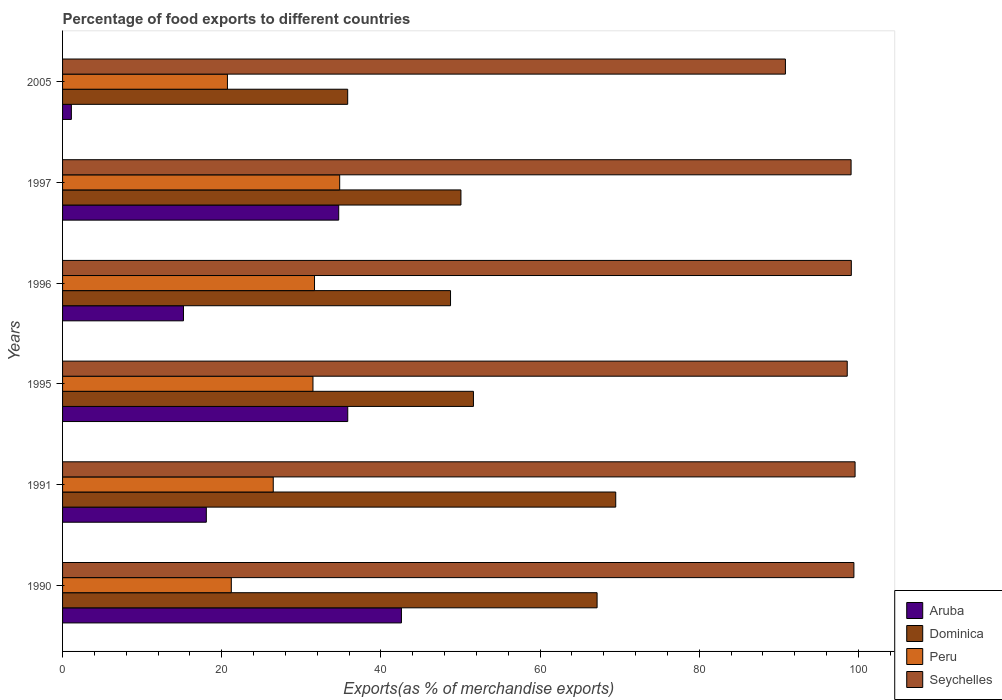Are the number of bars on each tick of the Y-axis equal?
Your answer should be very brief. Yes. How many bars are there on the 4th tick from the top?
Offer a very short reply. 4. How many bars are there on the 6th tick from the bottom?
Your answer should be compact. 4. What is the percentage of exports to different countries in Peru in 1995?
Keep it short and to the point. 31.46. Across all years, what is the maximum percentage of exports to different countries in Dominica?
Give a very brief answer. 69.51. Across all years, what is the minimum percentage of exports to different countries in Aruba?
Offer a very short reply. 1.11. What is the total percentage of exports to different countries in Aruba in the graph?
Offer a very short reply. 147.48. What is the difference between the percentage of exports to different countries in Dominica in 1996 and that in 2005?
Your answer should be compact. 12.92. What is the difference between the percentage of exports to different countries in Aruba in 1990 and the percentage of exports to different countries in Dominica in 1996?
Offer a very short reply. -6.17. What is the average percentage of exports to different countries in Dominica per year?
Keep it short and to the point. 53.82. In the year 1996, what is the difference between the percentage of exports to different countries in Seychelles and percentage of exports to different countries in Peru?
Your answer should be compact. 67.45. What is the ratio of the percentage of exports to different countries in Peru in 1995 to that in 2005?
Your answer should be very brief. 1.52. Is the difference between the percentage of exports to different countries in Seychelles in 1991 and 1995 greater than the difference between the percentage of exports to different countries in Peru in 1991 and 1995?
Make the answer very short. Yes. What is the difference between the highest and the second highest percentage of exports to different countries in Dominica?
Give a very brief answer. 2.34. What is the difference between the highest and the lowest percentage of exports to different countries in Aruba?
Provide a succinct answer. 41.47. Is the sum of the percentage of exports to different countries in Seychelles in 1991 and 2005 greater than the maximum percentage of exports to different countries in Peru across all years?
Offer a terse response. Yes. Is it the case that in every year, the sum of the percentage of exports to different countries in Seychelles and percentage of exports to different countries in Dominica is greater than the sum of percentage of exports to different countries in Aruba and percentage of exports to different countries in Peru?
Make the answer very short. Yes. What does the 2nd bar from the top in 1990 represents?
Your answer should be very brief. Peru. What does the 1st bar from the bottom in 1996 represents?
Your answer should be very brief. Aruba. Are all the bars in the graph horizontal?
Keep it short and to the point. Yes. How many years are there in the graph?
Offer a very short reply. 6. Are the values on the major ticks of X-axis written in scientific E-notation?
Your response must be concise. No. How are the legend labels stacked?
Your answer should be compact. Vertical. What is the title of the graph?
Make the answer very short. Percentage of food exports to different countries. Does "Mexico" appear as one of the legend labels in the graph?
Give a very brief answer. No. What is the label or title of the X-axis?
Provide a succinct answer. Exports(as % of merchandise exports). What is the Exports(as % of merchandise exports) in Aruba in 1990?
Your answer should be compact. 42.58. What is the Exports(as % of merchandise exports) of Dominica in 1990?
Make the answer very short. 67.17. What is the Exports(as % of merchandise exports) of Peru in 1990?
Your answer should be very brief. 21.2. What is the Exports(as % of merchandise exports) of Seychelles in 1990?
Provide a short and direct response. 99.43. What is the Exports(as % of merchandise exports) of Aruba in 1991?
Your answer should be compact. 18.06. What is the Exports(as % of merchandise exports) of Dominica in 1991?
Provide a succinct answer. 69.51. What is the Exports(as % of merchandise exports) of Peru in 1991?
Make the answer very short. 26.47. What is the Exports(as % of merchandise exports) in Seychelles in 1991?
Provide a succinct answer. 99.58. What is the Exports(as % of merchandise exports) of Aruba in 1995?
Keep it short and to the point. 35.83. What is the Exports(as % of merchandise exports) of Dominica in 1995?
Your response must be concise. 51.63. What is the Exports(as % of merchandise exports) in Peru in 1995?
Provide a succinct answer. 31.46. What is the Exports(as % of merchandise exports) in Seychelles in 1995?
Give a very brief answer. 98.6. What is the Exports(as % of merchandise exports) in Aruba in 1996?
Make the answer very short. 15.19. What is the Exports(as % of merchandise exports) of Dominica in 1996?
Keep it short and to the point. 48.75. What is the Exports(as % of merchandise exports) in Peru in 1996?
Make the answer very short. 31.66. What is the Exports(as % of merchandise exports) in Seychelles in 1996?
Provide a short and direct response. 99.11. What is the Exports(as % of merchandise exports) in Aruba in 1997?
Keep it short and to the point. 34.7. What is the Exports(as % of merchandise exports) of Dominica in 1997?
Your response must be concise. 50.06. What is the Exports(as % of merchandise exports) of Peru in 1997?
Provide a short and direct response. 34.82. What is the Exports(as % of merchandise exports) of Seychelles in 1997?
Your answer should be compact. 99.08. What is the Exports(as % of merchandise exports) of Aruba in 2005?
Your answer should be very brief. 1.11. What is the Exports(as % of merchandise exports) of Dominica in 2005?
Keep it short and to the point. 35.83. What is the Exports(as % of merchandise exports) of Peru in 2005?
Offer a very short reply. 20.72. What is the Exports(as % of merchandise exports) of Seychelles in 2005?
Offer a terse response. 90.83. Across all years, what is the maximum Exports(as % of merchandise exports) in Aruba?
Ensure brevity in your answer.  42.58. Across all years, what is the maximum Exports(as % of merchandise exports) of Dominica?
Your response must be concise. 69.51. Across all years, what is the maximum Exports(as % of merchandise exports) of Peru?
Your answer should be very brief. 34.82. Across all years, what is the maximum Exports(as % of merchandise exports) in Seychelles?
Your response must be concise. 99.58. Across all years, what is the minimum Exports(as % of merchandise exports) of Aruba?
Your response must be concise. 1.11. Across all years, what is the minimum Exports(as % of merchandise exports) of Dominica?
Provide a short and direct response. 35.83. Across all years, what is the minimum Exports(as % of merchandise exports) in Peru?
Give a very brief answer. 20.72. Across all years, what is the minimum Exports(as % of merchandise exports) in Seychelles?
Provide a succinct answer. 90.83. What is the total Exports(as % of merchandise exports) of Aruba in the graph?
Give a very brief answer. 147.48. What is the total Exports(as % of merchandise exports) of Dominica in the graph?
Your answer should be very brief. 322.93. What is the total Exports(as % of merchandise exports) of Peru in the graph?
Keep it short and to the point. 166.34. What is the total Exports(as % of merchandise exports) of Seychelles in the graph?
Your answer should be very brief. 586.63. What is the difference between the Exports(as % of merchandise exports) of Aruba in 1990 and that in 1991?
Ensure brevity in your answer.  24.52. What is the difference between the Exports(as % of merchandise exports) of Dominica in 1990 and that in 1991?
Offer a terse response. -2.34. What is the difference between the Exports(as % of merchandise exports) in Peru in 1990 and that in 1991?
Ensure brevity in your answer.  -5.27. What is the difference between the Exports(as % of merchandise exports) of Seychelles in 1990 and that in 1991?
Give a very brief answer. -0.15. What is the difference between the Exports(as % of merchandise exports) in Aruba in 1990 and that in 1995?
Provide a succinct answer. 6.74. What is the difference between the Exports(as % of merchandise exports) of Dominica in 1990 and that in 1995?
Offer a very short reply. 15.54. What is the difference between the Exports(as % of merchandise exports) of Peru in 1990 and that in 1995?
Keep it short and to the point. -10.26. What is the difference between the Exports(as % of merchandise exports) in Seychelles in 1990 and that in 1995?
Offer a very short reply. 0.84. What is the difference between the Exports(as % of merchandise exports) of Aruba in 1990 and that in 1996?
Your response must be concise. 27.38. What is the difference between the Exports(as % of merchandise exports) in Dominica in 1990 and that in 1996?
Provide a short and direct response. 18.42. What is the difference between the Exports(as % of merchandise exports) in Peru in 1990 and that in 1996?
Keep it short and to the point. -10.46. What is the difference between the Exports(as % of merchandise exports) of Seychelles in 1990 and that in 1996?
Ensure brevity in your answer.  0.32. What is the difference between the Exports(as % of merchandise exports) in Aruba in 1990 and that in 1997?
Your answer should be very brief. 7.88. What is the difference between the Exports(as % of merchandise exports) of Dominica in 1990 and that in 1997?
Provide a short and direct response. 17.11. What is the difference between the Exports(as % of merchandise exports) of Peru in 1990 and that in 1997?
Your answer should be very brief. -13.62. What is the difference between the Exports(as % of merchandise exports) in Seychelles in 1990 and that in 1997?
Provide a succinct answer. 0.35. What is the difference between the Exports(as % of merchandise exports) of Aruba in 1990 and that in 2005?
Keep it short and to the point. 41.47. What is the difference between the Exports(as % of merchandise exports) of Dominica in 1990 and that in 2005?
Offer a terse response. 31.34. What is the difference between the Exports(as % of merchandise exports) in Peru in 1990 and that in 2005?
Make the answer very short. 0.49. What is the difference between the Exports(as % of merchandise exports) of Seychelles in 1990 and that in 2005?
Provide a short and direct response. 8.61. What is the difference between the Exports(as % of merchandise exports) in Aruba in 1991 and that in 1995?
Your answer should be compact. -17.77. What is the difference between the Exports(as % of merchandise exports) in Dominica in 1991 and that in 1995?
Provide a short and direct response. 17.88. What is the difference between the Exports(as % of merchandise exports) in Peru in 1991 and that in 1995?
Your answer should be very brief. -4.99. What is the difference between the Exports(as % of merchandise exports) of Seychelles in 1991 and that in 1995?
Your response must be concise. 0.99. What is the difference between the Exports(as % of merchandise exports) of Aruba in 1991 and that in 1996?
Keep it short and to the point. 2.87. What is the difference between the Exports(as % of merchandise exports) in Dominica in 1991 and that in 1996?
Make the answer very short. 20.76. What is the difference between the Exports(as % of merchandise exports) in Peru in 1991 and that in 1996?
Provide a short and direct response. -5.18. What is the difference between the Exports(as % of merchandise exports) in Seychelles in 1991 and that in 1996?
Your response must be concise. 0.47. What is the difference between the Exports(as % of merchandise exports) in Aruba in 1991 and that in 1997?
Ensure brevity in your answer.  -16.64. What is the difference between the Exports(as % of merchandise exports) of Dominica in 1991 and that in 1997?
Your answer should be very brief. 19.45. What is the difference between the Exports(as % of merchandise exports) of Peru in 1991 and that in 1997?
Give a very brief answer. -8.35. What is the difference between the Exports(as % of merchandise exports) in Seychelles in 1991 and that in 1997?
Offer a very short reply. 0.5. What is the difference between the Exports(as % of merchandise exports) of Aruba in 1991 and that in 2005?
Your answer should be compact. 16.96. What is the difference between the Exports(as % of merchandise exports) in Dominica in 1991 and that in 2005?
Your response must be concise. 33.68. What is the difference between the Exports(as % of merchandise exports) in Peru in 1991 and that in 2005?
Your answer should be compact. 5.76. What is the difference between the Exports(as % of merchandise exports) in Seychelles in 1991 and that in 2005?
Provide a short and direct response. 8.75. What is the difference between the Exports(as % of merchandise exports) in Aruba in 1995 and that in 1996?
Offer a terse response. 20.64. What is the difference between the Exports(as % of merchandise exports) of Dominica in 1995 and that in 1996?
Give a very brief answer. 2.88. What is the difference between the Exports(as % of merchandise exports) in Peru in 1995 and that in 1996?
Provide a succinct answer. -0.19. What is the difference between the Exports(as % of merchandise exports) of Seychelles in 1995 and that in 1996?
Offer a terse response. -0.51. What is the difference between the Exports(as % of merchandise exports) in Aruba in 1995 and that in 1997?
Give a very brief answer. 1.13. What is the difference between the Exports(as % of merchandise exports) in Dominica in 1995 and that in 1997?
Your response must be concise. 1.57. What is the difference between the Exports(as % of merchandise exports) of Peru in 1995 and that in 1997?
Ensure brevity in your answer.  -3.36. What is the difference between the Exports(as % of merchandise exports) of Seychelles in 1995 and that in 1997?
Offer a terse response. -0.48. What is the difference between the Exports(as % of merchandise exports) in Aruba in 1995 and that in 2005?
Give a very brief answer. 34.73. What is the difference between the Exports(as % of merchandise exports) of Dominica in 1995 and that in 2005?
Your answer should be very brief. 15.8. What is the difference between the Exports(as % of merchandise exports) of Peru in 1995 and that in 2005?
Provide a short and direct response. 10.75. What is the difference between the Exports(as % of merchandise exports) of Seychelles in 1995 and that in 2005?
Offer a terse response. 7.77. What is the difference between the Exports(as % of merchandise exports) of Aruba in 1996 and that in 1997?
Provide a succinct answer. -19.5. What is the difference between the Exports(as % of merchandise exports) in Dominica in 1996 and that in 1997?
Give a very brief answer. -1.31. What is the difference between the Exports(as % of merchandise exports) of Peru in 1996 and that in 1997?
Keep it short and to the point. -3.16. What is the difference between the Exports(as % of merchandise exports) of Seychelles in 1996 and that in 1997?
Give a very brief answer. 0.03. What is the difference between the Exports(as % of merchandise exports) of Aruba in 1996 and that in 2005?
Provide a succinct answer. 14.09. What is the difference between the Exports(as % of merchandise exports) of Dominica in 1996 and that in 2005?
Make the answer very short. 12.92. What is the difference between the Exports(as % of merchandise exports) in Peru in 1996 and that in 2005?
Your answer should be compact. 10.94. What is the difference between the Exports(as % of merchandise exports) in Seychelles in 1996 and that in 2005?
Provide a short and direct response. 8.28. What is the difference between the Exports(as % of merchandise exports) in Aruba in 1997 and that in 2005?
Your answer should be very brief. 33.59. What is the difference between the Exports(as % of merchandise exports) in Dominica in 1997 and that in 2005?
Make the answer very short. 14.23. What is the difference between the Exports(as % of merchandise exports) of Peru in 1997 and that in 2005?
Offer a terse response. 14.1. What is the difference between the Exports(as % of merchandise exports) in Seychelles in 1997 and that in 2005?
Ensure brevity in your answer.  8.25. What is the difference between the Exports(as % of merchandise exports) in Aruba in 1990 and the Exports(as % of merchandise exports) in Dominica in 1991?
Your answer should be very brief. -26.93. What is the difference between the Exports(as % of merchandise exports) of Aruba in 1990 and the Exports(as % of merchandise exports) of Peru in 1991?
Offer a terse response. 16.11. What is the difference between the Exports(as % of merchandise exports) of Aruba in 1990 and the Exports(as % of merchandise exports) of Seychelles in 1991?
Offer a very short reply. -57. What is the difference between the Exports(as % of merchandise exports) in Dominica in 1990 and the Exports(as % of merchandise exports) in Peru in 1991?
Keep it short and to the point. 40.69. What is the difference between the Exports(as % of merchandise exports) in Dominica in 1990 and the Exports(as % of merchandise exports) in Seychelles in 1991?
Provide a succinct answer. -32.42. What is the difference between the Exports(as % of merchandise exports) of Peru in 1990 and the Exports(as % of merchandise exports) of Seychelles in 1991?
Your response must be concise. -78.38. What is the difference between the Exports(as % of merchandise exports) in Aruba in 1990 and the Exports(as % of merchandise exports) in Dominica in 1995?
Your answer should be compact. -9.05. What is the difference between the Exports(as % of merchandise exports) in Aruba in 1990 and the Exports(as % of merchandise exports) in Peru in 1995?
Give a very brief answer. 11.11. What is the difference between the Exports(as % of merchandise exports) of Aruba in 1990 and the Exports(as % of merchandise exports) of Seychelles in 1995?
Make the answer very short. -56.02. What is the difference between the Exports(as % of merchandise exports) of Dominica in 1990 and the Exports(as % of merchandise exports) of Peru in 1995?
Your answer should be compact. 35.7. What is the difference between the Exports(as % of merchandise exports) of Dominica in 1990 and the Exports(as % of merchandise exports) of Seychelles in 1995?
Your answer should be very brief. -31.43. What is the difference between the Exports(as % of merchandise exports) of Peru in 1990 and the Exports(as % of merchandise exports) of Seychelles in 1995?
Make the answer very short. -77.39. What is the difference between the Exports(as % of merchandise exports) of Aruba in 1990 and the Exports(as % of merchandise exports) of Dominica in 1996?
Ensure brevity in your answer.  -6.17. What is the difference between the Exports(as % of merchandise exports) of Aruba in 1990 and the Exports(as % of merchandise exports) of Peru in 1996?
Keep it short and to the point. 10.92. What is the difference between the Exports(as % of merchandise exports) in Aruba in 1990 and the Exports(as % of merchandise exports) in Seychelles in 1996?
Give a very brief answer. -56.53. What is the difference between the Exports(as % of merchandise exports) in Dominica in 1990 and the Exports(as % of merchandise exports) in Peru in 1996?
Keep it short and to the point. 35.51. What is the difference between the Exports(as % of merchandise exports) in Dominica in 1990 and the Exports(as % of merchandise exports) in Seychelles in 1996?
Offer a very short reply. -31.95. What is the difference between the Exports(as % of merchandise exports) of Peru in 1990 and the Exports(as % of merchandise exports) of Seychelles in 1996?
Make the answer very short. -77.91. What is the difference between the Exports(as % of merchandise exports) of Aruba in 1990 and the Exports(as % of merchandise exports) of Dominica in 1997?
Keep it short and to the point. -7.48. What is the difference between the Exports(as % of merchandise exports) in Aruba in 1990 and the Exports(as % of merchandise exports) in Peru in 1997?
Offer a very short reply. 7.76. What is the difference between the Exports(as % of merchandise exports) of Aruba in 1990 and the Exports(as % of merchandise exports) of Seychelles in 1997?
Your response must be concise. -56.5. What is the difference between the Exports(as % of merchandise exports) in Dominica in 1990 and the Exports(as % of merchandise exports) in Peru in 1997?
Your answer should be very brief. 32.34. What is the difference between the Exports(as % of merchandise exports) of Dominica in 1990 and the Exports(as % of merchandise exports) of Seychelles in 1997?
Ensure brevity in your answer.  -31.91. What is the difference between the Exports(as % of merchandise exports) of Peru in 1990 and the Exports(as % of merchandise exports) of Seychelles in 1997?
Your answer should be very brief. -77.88. What is the difference between the Exports(as % of merchandise exports) in Aruba in 1990 and the Exports(as % of merchandise exports) in Dominica in 2005?
Your answer should be very brief. 6.75. What is the difference between the Exports(as % of merchandise exports) in Aruba in 1990 and the Exports(as % of merchandise exports) in Peru in 2005?
Make the answer very short. 21.86. What is the difference between the Exports(as % of merchandise exports) in Aruba in 1990 and the Exports(as % of merchandise exports) in Seychelles in 2005?
Ensure brevity in your answer.  -48.25. What is the difference between the Exports(as % of merchandise exports) of Dominica in 1990 and the Exports(as % of merchandise exports) of Peru in 2005?
Provide a succinct answer. 46.45. What is the difference between the Exports(as % of merchandise exports) in Dominica in 1990 and the Exports(as % of merchandise exports) in Seychelles in 2005?
Provide a short and direct response. -23.66. What is the difference between the Exports(as % of merchandise exports) of Peru in 1990 and the Exports(as % of merchandise exports) of Seychelles in 2005?
Offer a terse response. -69.63. What is the difference between the Exports(as % of merchandise exports) in Aruba in 1991 and the Exports(as % of merchandise exports) in Dominica in 1995?
Offer a terse response. -33.56. What is the difference between the Exports(as % of merchandise exports) in Aruba in 1991 and the Exports(as % of merchandise exports) in Peru in 1995?
Your answer should be very brief. -13.4. What is the difference between the Exports(as % of merchandise exports) of Aruba in 1991 and the Exports(as % of merchandise exports) of Seychelles in 1995?
Provide a short and direct response. -80.53. What is the difference between the Exports(as % of merchandise exports) of Dominica in 1991 and the Exports(as % of merchandise exports) of Peru in 1995?
Offer a terse response. 38.04. What is the difference between the Exports(as % of merchandise exports) in Dominica in 1991 and the Exports(as % of merchandise exports) in Seychelles in 1995?
Provide a short and direct response. -29.09. What is the difference between the Exports(as % of merchandise exports) of Peru in 1991 and the Exports(as % of merchandise exports) of Seychelles in 1995?
Ensure brevity in your answer.  -72.12. What is the difference between the Exports(as % of merchandise exports) of Aruba in 1991 and the Exports(as % of merchandise exports) of Dominica in 1996?
Your response must be concise. -30.68. What is the difference between the Exports(as % of merchandise exports) of Aruba in 1991 and the Exports(as % of merchandise exports) of Peru in 1996?
Ensure brevity in your answer.  -13.6. What is the difference between the Exports(as % of merchandise exports) of Aruba in 1991 and the Exports(as % of merchandise exports) of Seychelles in 1996?
Your response must be concise. -81.05. What is the difference between the Exports(as % of merchandise exports) in Dominica in 1991 and the Exports(as % of merchandise exports) in Peru in 1996?
Provide a succinct answer. 37.85. What is the difference between the Exports(as % of merchandise exports) of Dominica in 1991 and the Exports(as % of merchandise exports) of Seychelles in 1996?
Make the answer very short. -29.6. What is the difference between the Exports(as % of merchandise exports) in Peru in 1991 and the Exports(as % of merchandise exports) in Seychelles in 1996?
Make the answer very short. -72.64. What is the difference between the Exports(as % of merchandise exports) in Aruba in 1991 and the Exports(as % of merchandise exports) in Dominica in 1997?
Provide a short and direct response. -31.99. What is the difference between the Exports(as % of merchandise exports) in Aruba in 1991 and the Exports(as % of merchandise exports) in Peru in 1997?
Provide a short and direct response. -16.76. What is the difference between the Exports(as % of merchandise exports) of Aruba in 1991 and the Exports(as % of merchandise exports) of Seychelles in 1997?
Provide a succinct answer. -81.02. What is the difference between the Exports(as % of merchandise exports) in Dominica in 1991 and the Exports(as % of merchandise exports) in Peru in 1997?
Make the answer very short. 34.69. What is the difference between the Exports(as % of merchandise exports) of Dominica in 1991 and the Exports(as % of merchandise exports) of Seychelles in 1997?
Your response must be concise. -29.57. What is the difference between the Exports(as % of merchandise exports) of Peru in 1991 and the Exports(as % of merchandise exports) of Seychelles in 1997?
Provide a short and direct response. -72.61. What is the difference between the Exports(as % of merchandise exports) of Aruba in 1991 and the Exports(as % of merchandise exports) of Dominica in 2005?
Make the answer very short. -17.76. What is the difference between the Exports(as % of merchandise exports) of Aruba in 1991 and the Exports(as % of merchandise exports) of Peru in 2005?
Keep it short and to the point. -2.65. What is the difference between the Exports(as % of merchandise exports) of Aruba in 1991 and the Exports(as % of merchandise exports) of Seychelles in 2005?
Provide a short and direct response. -72.77. What is the difference between the Exports(as % of merchandise exports) in Dominica in 1991 and the Exports(as % of merchandise exports) in Peru in 2005?
Make the answer very short. 48.79. What is the difference between the Exports(as % of merchandise exports) of Dominica in 1991 and the Exports(as % of merchandise exports) of Seychelles in 2005?
Ensure brevity in your answer.  -21.32. What is the difference between the Exports(as % of merchandise exports) in Peru in 1991 and the Exports(as % of merchandise exports) in Seychelles in 2005?
Provide a succinct answer. -64.35. What is the difference between the Exports(as % of merchandise exports) in Aruba in 1995 and the Exports(as % of merchandise exports) in Dominica in 1996?
Ensure brevity in your answer.  -12.91. What is the difference between the Exports(as % of merchandise exports) of Aruba in 1995 and the Exports(as % of merchandise exports) of Peru in 1996?
Your answer should be very brief. 4.18. What is the difference between the Exports(as % of merchandise exports) in Aruba in 1995 and the Exports(as % of merchandise exports) in Seychelles in 1996?
Provide a succinct answer. -63.28. What is the difference between the Exports(as % of merchandise exports) of Dominica in 1995 and the Exports(as % of merchandise exports) of Peru in 1996?
Give a very brief answer. 19.97. What is the difference between the Exports(as % of merchandise exports) in Dominica in 1995 and the Exports(as % of merchandise exports) in Seychelles in 1996?
Give a very brief answer. -47.48. What is the difference between the Exports(as % of merchandise exports) of Peru in 1995 and the Exports(as % of merchandise exports) of Seychelles in 1996?
Provide a succinct answer. -67.65. What is the difference between the Exports(as % of merchandise exports) of Aruba in 1995 and the Exports(as % of merchandise exports) of Dominica in 1997?
Your answer should be compact. -14.22. What is the difference between the Exports(as % of merchandise exports) in Aruba in 1995 and the Exports(as % of merchandise exports) in Peru in 1997?
Ensure brevity in your answer.  1.01. What is the difference between the Exports(as % of merchandise exports) in Aruba in 1995 and the Exports(as % of merchandise exports) in Seychelles in 1997?
Your response must be concise. -63.25. What is the difference between the Exports(as % of merchandise exports) in Dominica in 1995 and the Exports(as % of merchandise exports) in Peru in 1997?
Make the answer very short. 16.8. What is the difference between the Exports(as % of merchandise exports) of Dominica in 1995 and the Exports(as % of merchandise exports) of Seychelles in 1997?
Make the answer very short. -47.45. What is the difference between the Exports(as % of merchandise exports) in Peru in 1995 and the Exports(as % of merchandise exports) in Seychelles in 1997?
Ensure brevity in your answer.  -67.62. What is the difference between the Exports(as % of merchandise exports) in Aruba in 1995 and the Exports(as % of merchandise exports) in Dominica in 2005?
Offer a very short reply. 0.01. What is the difference between the Exports(as % of merchandise exports) in Aruba in 1995 and the Exports(as % of merchandise exports) in Peru in 2005?
Offer a very short reply. 15.12. What is the difference between the Exports(as % of merchandise exports) of Aruba in 1995 and the Exports(as % of merchandise exports) of Seychelles in 2005?
Your answer should be very brief. -54.99. What is the difference between the Exports(as % of merchandise exports) in Dominica in 1995 and the Exports(as % of merchandise exports) in Peru in 2005?
Offer a terse response. 30.91. What is the difference between the Exports(as % of merchandise exports) of Dominica in 1995 and the Exports(as % of merchandise exports) of Seychelles in 2005?
Make the answer very short. -39.2. What is the difference between the Exports(as % of merchandise exports) of Peru in 1995 and the Exports(as % of merchandise exports) of Seychelles in 2005?
Provide a succinct answer. -59.36. What is the difference between the Exports(as % of merchandise exports) of Aruba in 1996 and the Exports(as % of merchandise exports) of Dominica in 1997?
Provide a short and direct response. -34.86. What is the difference between the Exports(as % of merchandise exports) of Aruba in 1996 and the Exports(as % of merchandise exports) of Peru in 1997?
Ensure brevity in your answer.  -19.63. What is the difference between the Exports(as % of merchandise exports) of Aruba in 1996 and the Exports(as % of merchandise exports) of Seychelles in 1997?
Your response must be concise. -83.89. What is the difference between the Exports(as % of merchandise exports) in Dominica in 1996 and the Exports(as % of merchandise exports) in Peru in 1997?
Give a very brief answer. 13.93. What is the difference between the Exports(as % of merchandise exports) of Dominica in 1996 and the Exports(as % of merchandise exports) of Seychelles in 1997?
Your response must be concise. -50.33. What is the difference between the Exports(as % of merchandise exports) of Peru in 1996 and the Exports(as % of merchandise exports) of Seychelles in 1997?
Provide a succinct answer. -67.42. What is the difference between the Exports(as % of merchandise exports) in Aruba in 1996 and the Exports(as % of merchandise exports) in Dominica in 2005?
Keep it short and to the point. -20.63. What is the difference between the Exports(as % of merchandise exports) in Aruba in 1996 and the Exports(as % of merchandise exports) in Peru in 2005?
Give a very brief answer. -5.52. What is the difference between the Exports(as % of merchandise exports) in Aruba in 1996 and the Exports(as % of merchandise exports) in Seychelles in 2005?
Your answer should be very brief. -75.63. What is the difference between the Exports(as % of merchandise exports) in Dominica in 1996 and the Exports(as % of merchandise exports) in Peru in 2005?
Your response must be concise. 28.03. What is the difference between the Exports(as % of merchandise exports) in Dominica in 1996 and the Exports(as % of merchandise exports) in Seychelles in 2005?
Give a very brief answer. -42.08. What is the difference between the Exports(as % of merchandise exports) in Peru in 1996 and the Exports(as % of merchandise exports) in Seychelles in 2005?
Your response must be concise. -59.17. What is the difference between the Exports(as % of merchandise exports) in Aruba in 1997 and the Exports(as % of merchandise exports) in Dominica in 2005?
Keep it short and to the point. -1.13. What is the difference between the Exports(as % of merchandise exports) of Aruba in 1997 and the Exports(as % of merchandise exports) of Peru in 2005?
Your answer should be compact. 13.98. What is the difference between the Exports(as % of merchandise exports) in Aruba in 1997 and the Exports(as % of merchandise exports) in Seychelles in 2005?
Ensure brevity in your answer.  -56.13. What is the difference between the Exports(as % of merchandise exports) of Dominica in 1997 and the Exports(as % of merchandise exports) of Peru in 2005?
Your response must be concise. 29.34. What is the difference between the Exports(as % of merchandise exports) in Dominica in 1997 and the Exports(as % of merchandise exports) in Seychelles in 2005?
Provide a short and direct response. -40.77. What is the difference between the Exports(as % of merchandise exports) in Peru in 1997 and the Exports(as % of merchandise exports) in Seychelles in 2005?
Ensure brevity in your answer.  -56.01. What is the average Exports(as % of merchandise exports) in Aruba per year?
Provide a short and direct response. 24.58. What is the average Exports(as % of merchandise exports) of Dominica per year?
Your answer should be very brief. 53.82. What is the average Exports(as % of merchandise exports) of Peru per year?
Offer a terse response. 27.72. What is the average Exports(as % of merchandise exports) in Seychelles per year?
Offer a terse response. 97.77. In the year 1990, what is the difference between the Exports(as % of merchandise exports) of Aruba and Exports(as % of merchandise exports) of Dominica?
Your answer should be compact. -24.59. In the year 1990, what is the difference between the Exports(as % of merchandise exports) in Aruba and Exports(as % of merchandise exports) in Peru?
Your answer should be compact. 21.38. In the year 1990, what is the difference between the Exports(as % of merchandise exports) in Aruba and Exports(as % of merchandise exports) in Seychelles?
Your response must be concise. -56.85. In the year 1990, what is the difference between the Exports(as % of merchandise exports) of Dominica and Exports(as % of merchandise exports) of Peru?
Provide a short and direct response. 45.96. In the year 1990, what is the difference between the Exports(as % of merchandise exports) in Dominica and Exports(as % of merchandise exports) in Seychelles?
Offer a terse response. -32.27. In the year 1990, what is the difference between the Exports(as % of merchandise exports) of Peru and Exports(as % of merchandise exports) of Seychelles?
Offer a very short reply. -78.23. In the year 1991, what is the difference between the Exports(as % of merchandise exports) of Aruba and Exports(as % of merchandise exports) of Dominica?
Provide a succinct answer. -51.44. In the year 1991, what is the difference between the Exports(as % of merchandise exports) of Aruba and Exports(as % of merchandise exports) of Peru?
Offer a very short reply. -8.41. In the year 1991, what is the difference between the Exports(as % of merchandise exports) of Aruba and Exports(as % of merchandise exports) of Seychelles?
Ensure brevity in your answer.  -81.52. In the year 1991, what is the difference between the Exports(as % of merchandise exports) of Dominica and Exports(as % of merchandise exports) of Peru?
Provide a succinct answer. 43.03. In the year 1991, what is the difference between the Exports(as % of merchandise exports) in Dominica and Exports(as % of merchandise exports) in Seychelles?
Keep it short and to the point. -30.07. In the year 1991, what is the difference between the Exports(as % of merchandise exports) of Peru and Exports(as % of merchandise exports) of Seychelles?
Keep it short and to the point. -73.11. In the year 1995, what is the difference between the Exports(as % of merchandise exports) of Aruba and Exports(as % of merchandise exports) of Dominica?
Offer a very short reply. -15.79. In the year 1995, what is the difference between the Exports(as % of merchandise exports) in Aruba and Exports(as % of merchandise exports) in Peru?
Your answer should be very brief. 4.37. In the year 1995, what is the difference between the Exports(as % of merchandise exports) of Aruba and Exports(as % of merchandise exports) of Seychelles?
Your answer should be compact. -62.76. In the year 1995, what is the difference between the Exports(as % of merchandise exports) of Dominica and Exports(as % of merchandise exports) of Peru?
Give a very brief answer. 20.16. In the year 1995, what is the difference between the Exports(as % of merchandise exports) in Dominica and Exports(as % of merchandise exports) in Seychelles?
Offer a terse response. -46.97. In the year 1995, what is the difference between the Exports(as % of merchandise exports) in Peru and Exports(as % of merchandise exports) in Seychelles?
Offer a very short reply. -67.13. In the year 1996, what is the difference between the Exports(as % of merchandise exports) in Aruba and Exports(as % of merchandise exports) in Dominica?
Keep it short and to the point. -33.55. In the year 1996, what is the difference between the Exports(as % of merchandise exports) of Aruba and Exports(as % of merchandise exports) of Peru?
Keep it short and to the point. -16.46. In the year 1996, what is the difference between the Exports(as % of merchandise exports) of Aruba and Exports(as % of merchandise exports) of Seychelles?
Provide a short and direct response. -83.92. In the year 1996, what is the difference between the Exports(as % of merchandise exports) in Dominica and Exports(as % of merchandise exports) in Peru?
Ensure brevity in your answer.  17.09. In the year 1996, what is the difference between the Exports(as % of merchandise exports) in Dominica and Exports(as % of merchandise exports) in Seychelles?
Provide a succinct answer. -50.36. In the year 1996, what is the difference between the Exports(as % of merchandise exports) of Peru and Exports(as % of merchandise exports) of Seychelles?
Offer a very short reply. -67.45. In the year 1997, what is the difference between the Exports(as % of merchandise exports) in Aruba and Exports(as % of merchandise exports) in Dominica?
Provide a succinct answer. -15.36. In the year 1997, what is the difference between the Exports(as % of merchandise exports) in Aruba and Exports(as % of merchandise exports) in Peru?
Your response must be concise. -0.12. In the year 1997, what is the difference between the Exports(as % of merchandise exports) of Aruba and Exports(as % of merchandise exports) of Seychelles?
Ensure brevity in your answer.  -64.38. In the year 1997, what is the difference between the Exports(as % of merchandise exports) of Dominica and Exports(as % of merchandise exports) of Peru?
Offer a very short reply. 15.24. In the year 1997, what is the difference between the Exports(as % of merchandise exports) in Dominica and Exports(as % of merchandise exports) in Seychelles?
Offer a very short reply. -49.02. In the year 1997, what is the difference between the Exports(as % of merchandise exports) in Peru and Exports(as % of merchandise exports) in Seychelles?
Your answer should be very brief. -64.26. In the year 2005, what is the difference between the Exports(as % of merchandise exports) in Aruba and Exports(as % of merchandise exports) in Dominica?
Your response must be concise. -34.72. In the year 2005, what is the difference between the Exports(as % of merchandise exports) in Aruba and Exports(as % of merchandise exports) in Peru?
Your answer should be very brief. -19.61. In the year 2005, what is the difference between the Exports(as % of merchandise exports) in Aruba and Exports(as % of merchandise exports) in Seychelles?
Offer a very short reply. -89.72. In the year 2005, what is the difference between the Exports(as % of merchandise exports) in Dominica and Exports(as % of merchandise exports) in Peru?
Your answer should be very brief. 15.11. In the year 2005, what is the difference between the Exports(as % of merchandise exports) of Dominica and Exports(as % of merchandise exports) of Seychelles?
Keep it short and to the point. -55. In the year 2005, what is the difference between the Exports(as % of merchandise exports) of Peru and Exports(as % of merchandise exports) of Seychelles?
Provide a succinct answer. -70.11. What is the ratio of the Exports(as % of merchandise exports) of Aruba in 1990 to that in 1991?
Ensure brevity in your answer.  2.36. What is the ratio of the Exports(as % of merchandise exports) of Dominica in 1990 to that in 1991?
Keep it short and to the point. 0.97. What is the ratio of the Exports(as % of merchandise exports) in Peru in 1990 to that in 1991?
Provide a short and direct response. 0.8. What is the ratio of the Exports(as % of merchandise exports) of Aruba in 1990 to that in 1995?
Keep it short and to the point. 1.19. What is the ratio of the Exports(as % of merchandise exports) in Dominica in 1990 to that in 1995?
Offer a terse response. 1.3. What is the ratio of the Exports(as % of merchandise exports) in Peru in 1990 to that in 1995?
Provide a short and direct response. 0.67. What is the ratio of the Exports(as % of merchandise exports) in Seychelles in 1990 to that in 1995?
Provide a succinct answer. 1.01. What is the ratio of the Exports(as % of merchandise exports) of Aruba in 1990 to that in 1996?
Keep it short and to the point. 2.8. What is the ratio of the Exports(as % of merchandise exports) in Dominica in 1990 to that in 1996?
Keep it short and to the point. 1.38. What is the ratio of the Exports(as % of merchandise exports) of Peru in 1990 to that in 1996?
Offer a very short reply. 0.67. What is the ratio of the Exports(as % of merchandise exports) in Seychelles in 1990 to that in 1996?
Provide a short and direct response. 1. What is the ratio of the Exports(as % of merchandise exports) of Aruba in 1990 to that in 1997?
Offer a terse response. 1.23. What is the ratio of the Exports(as % of merchandise exports) in Dominica in 1990 to that in 1997?
Offer a very short reply. 1.34. What is the ratio of the Exports(as % of merchandise exports) in Peru in 1990 to that in 1997?
Provide a short and direct response. 0.61. What is the ratio of the Exports(as % of merchandise exports) in Seychelles in 1990 to that in 1997?
Make the answer very short. 1. What is the ratio of the Exports(as % of merchandise exports) of Aruba in 1990 to that in 2005?
Your answer should be very brief. 38.48. What is the ratio of the Exports(as % of merchandise exports) of Dominica in 1990 to that in 2005?
Make the answer very short. 1.87. What is the ratio of the Exports(as % of merchandise exports) in Peru in 1990 to that in 2005?
Provide a succinct answer. 1.02. What is the ratio of the Exports(as % of merchandise exports) in Seychelles in 1990 to that in 2005?
Keep it short and to the point. 1.09. What is the ratio of the Exports(as % of merchandise exports) of Aruba in 1991 to that in 1995?
Your answer should be very brief. 0.5. What is the ratio of the Exports(as % of merchandise exports) in Dominica in 1991 to that in 1995?
Make the answer very short. 1.35. What is the ratio of the Exports(as % of merchandise exports) in Peru in 1991 to that in 1995?
Provide a succinct answer. 0.84. What is the ratio of the Exports(as % of merchandise exports) in Seychelles in 1991 to that in 1995?
Make the answer very short. 1.01. What is the ratio of the Exports(as % of merchandise exports) of Aruba in 1991 to that in 1996?
Your answer should be compact. 1.19. What is the ratio of the Exports(as % of merchandise exports) in Dominica in 1991 to that in 1996?
Provide a succinct answer. 1.43. What is the ratio of the Exports(as % of merchandise exports) of Peru in 1991 to that in 1996?
Provide a short and direct response. 0.84. What is the ratio of the Exports(as % of merchandise exports) in Aruba in 1991 to that in 1997?
Your response must be concise. 0.52. What is the ratio of the Exports(as % of merchandise exports) in Dominica in 1991 to that in 1997?
Give a very brief answer. 1.39. What is the ratio of the Exports(as % of merchandise exports) of Peru in 1991 to that in 1997?
Your answer should be very brief. 0.76. What is the ratio of the Exports(as % of merchandise exports) of Seychelles in 1991 to that in 1997?
Provide a succinct answer. 1.01. What is the ratio of the Exports(as % of merchandise exports) in Aruba in 1991 to that in 2005?
Make the answer very short. 16.33. What is the ratio of the Exports(as % of merchandise exports) in Dominica in 1991 to that in 2005?
Your response must be concise. 1.94. What is the ratio of the Exports(as % of merchandise exports) of Peru in 1991 to that in 2005?
Give a very brief answer. 1.28. What is the ratio of the Exports(as % of merchandise exports) of Seychelles in 1991 to that in 2005?
Provide a short and direct response. 1.1. What is the ratio of the Exports(as % of merchandise exports) in Aruba in 1995 to that in 1996?
Make the answer very short. 2.36. What is the ratio of the Exports(as % of merchandise exports) in Dominica in 1995 to that in 1996?
Give a very brief answer. 1.06. What is the ratio of the Exports(as % of merchandise exports) of Aruba in 1995 to that in 1997?
Your response must be concise. 1.03. What is the ratio of the Exports(as % of merchandise exports) in Dominica in 1995 to that in 1997?
Keep it short and to the point. 1.03. What is the ratio of the Exports(as % of merchandise exports) of Peru in 1995 to that in 1997?
Make the answer very short. 0.9. What is the ratio of the Exports(as % of merchandise exports) of Aruba in 1995 to that in 2005?
Keep it short and to the point. 32.39. What is the ratio of the Exports(as % of merchandise exports) in Dominica in 1995 to that in 2005?
Provide a short and direct response. 1.44. What is the ratio of the Exports(as % of merchandise exports) of Peru in 1995 to that in 2005?
Keep it short and to the point. 1.52. What is the ratio of the Exports(as % of merchandise exports) in Seychelles in 1995 to that in 2005?
Give a very brief answer. 1.09. What is the ratio of the Exports(as % of merchandise exports) in Aruba in 1996 to that in 1997?
Your response must be concise. 0.44. What is the ratio of the Exports(as % of merchandise exports) in Dominica in 1996 to that in 1997?
Your response must be concise. 0.97. What is the ratio of the Exports(as % of merchandise exports) in Peru in 1996 to that in 1997?
Make the answer very short. 0.91. What is the ratio of the Exports(as % of merchandise exports) of Aruba in 1996 to that in 2005?
Provide a short and direct response. 13.73. What is the ratio of the Exports(as % of merchandise exports) in Dominica in 1996 to that in 2005?
Give a very brief answer. 1.36. What is the ratio of the Exports(as % of merchandise exports) in Peru in 1996 to that in 2005?
Give a very brief answer. 1.53. What is the ratio of the Exports(as % of merchandise exports) of Seychelles in 1996 to that in 2005?
Ensure brevity in your answer.  1.09. What is the ratio of the Exports(as % of merchandise exports) in Aruba in 1997 to that in 2005?
Your answer should be compact. 31.36. What is the ratio of the Exports(as % of merchandise exports) of Dominica in 1997 to that in 2005?
Ensure brevity in your answer.  1.4. What is the ratio of the Exports(as % of merchandise exports) in Peru in 1997 to that in 2005?
Provide a short and direct response. 1.68. What is the ratio of the Exports(as % of merchandise exports) in Seychelles in 1997 to that in 2005?
Provide a short and direct response. 1.09. What is the difference between the highest and the second highest Exports(as % of merchandise exports) in Aruba?
Offer a terse response. 6.74. What is the difference between the highest and the second highest Exports(as % of merchandise exports) of Dominica?
Make the answer very short. 2.34. What is the difference between the highest and the second highest Exports(as % of merchandise exports) in Peru?
Provide a short and direct response. 3.16. What is the difference between the highest and the second highest Exports(as % of merchandise exports) of Seychelles?
Your response must be concise. 0.15. What is the difference between the highest and the lowest Exports(as % of merchandise exports) in Aruba?
Keep it short and to the point. 41.47. What is the difference between the highest and the lowest Exports(as % of merchandise exports) in Dominica?
Keep it short and to the point. 33.68. What is the difference between the highest and the lowest Exports(as % of merchandise exports) of Peru?
Ensure brevity in your answer.  14.1. What is the difference between the highest and the lowest Exports(as % of merchandise exports) of Seychelles?
Provide a short and direct response. 8.75. 